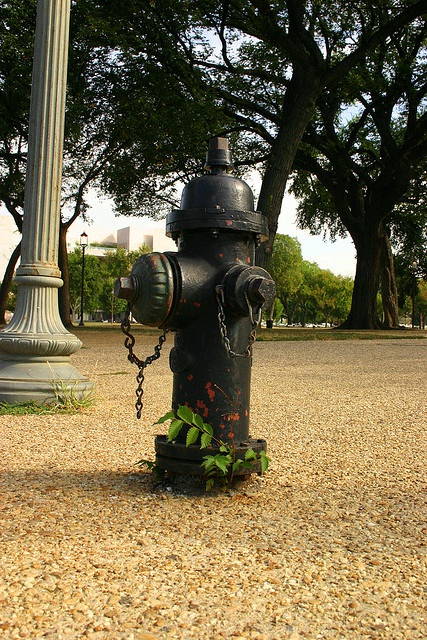Describe the objects in this image and their specific colors. I can see a fire hydrant in gray, black, darkgreen, and maroon tones in this image. 